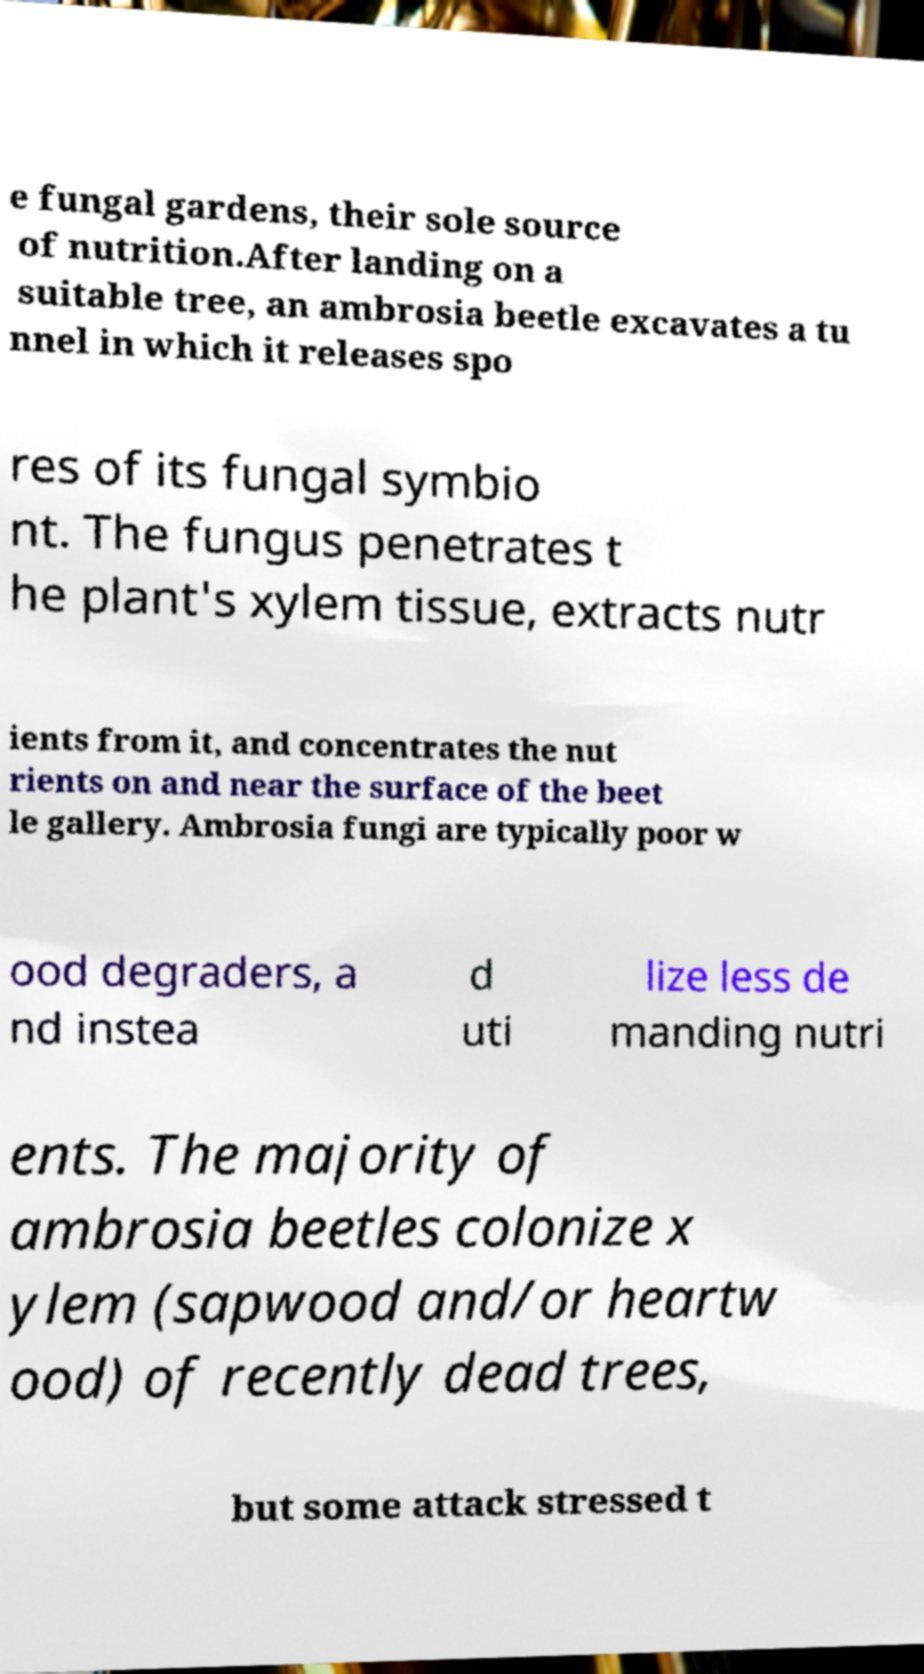Please read and relay the text visible in this image. What does it say? e fungal gardens, their sole source of nutrition.After landing on a suitable tree, an ambrosia beetle excavates a tu nnel in which it releases spo res of its fungal symbio nt. The fungus penetrates t he plant's xylem tissue, extracts nutr ients from it, and concentrates the nut rients on and near the surface of the beet le gallery. Ambrosia fungi are typically poor w ood degraders, a nd instea d uti lize less de manding nutri ents. The majority of ambrosia beetles colonize x ylem (sapwood and/or heartw ood) of recently dead trees, but some attack stressed t 